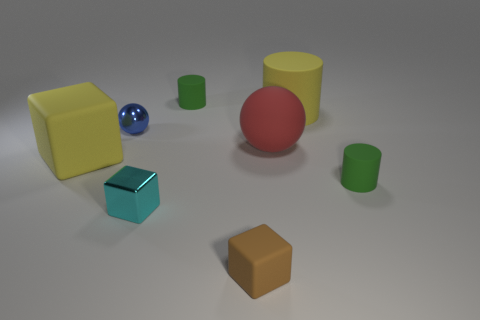Subtract 1 cubes. How many cubes are left? 2 Add 1 small blue things. How many objects exist? 9 Subtract all cylinders. How many objects are left? 5 Subtract all green things. Subtract all green objects. How many objects are left? 4 Add 6 green things. How many green things are left? 8 Add 3 small rubber objects. How many small rubber objects exist? 6 Subtract 1 blue spheres. How many objects are left? 7 